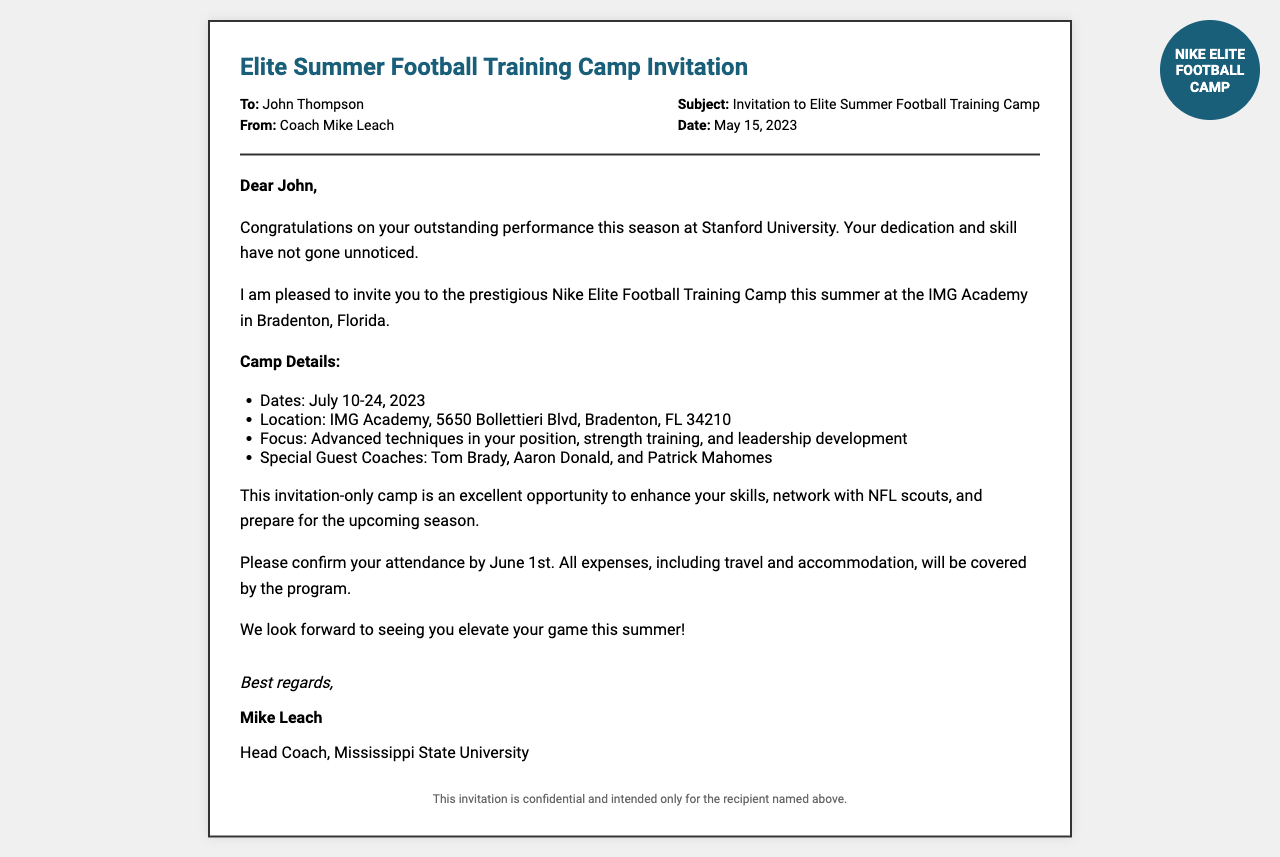What is the name of the camp? The camp is titled "Nike Elite Football Camp" as mentioned in the logo at the top right corner of the document.
Answer: Nike Elite Football Camp Who is the sender of the invitation? The invitation is sent by Coach Mike Leach, as noted in the sender section of the header.
Answer: Coach Mike Leach What are the camp dates? The camp dates are specified as July 10-24, 2023 in the camp details section of the document.
Answer: July 10-24, 2023 Where is the camp located? The location of the camp is indicated as IMG Academy, 5650 Bollettieri Blvd, Bradenton, FL 34210 in the document.
Answer: IMG Academy, 5650 Bollettieri Blvd, Bradenton, FL 34210 Which special guest coaches are mentioned? The document lists Tom Brady, Aaron Donald, and Patrick Mahomes as special guest coaches.
Answer: Tom Brady, Aaron Donald, Patrick Mahomes What is the deadline for confirming attendance? The deadline for confirmation is stated as June 1st in the invitation details.
Answer: June 1st What expenses will be covered by the program? The document mentions that all expenses, including travel and accommodation, will be covered by the program.
Answer: Travel and accommodation What is the purpose of the camp? The purpose of the camp is described as enhancing skills, networking with NFL scouts, and preparing for the upcoming season.
Answer: Enhance skills, network with NFL scouts, prepare for the upcoming season What does "invitation-only camp" imply? The term "invitation-only camp" implies that attendance is restricted to those who have specifically received an invitation.
Answer: Restricted attendance 